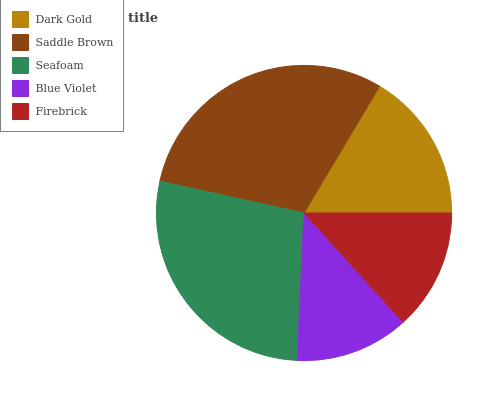Is Blue Violet the minimum?
Answer yes or no. Yes. Is Saddle Brown the maximum?
Answer yes or no. Yes. Is Seafoam the minimum?
Answer yes or no. No. Is Seafoam the maximum?
Answer yes or no. No. Is Saddle Brown greater than Seafoam?
Answer yes or no. Yes. Is Seafoam less than Saddle Brown?
Answer yes or no. Yes. Is Seafoam greater than Saddle Brown?
Answer yes or no. No. Is Saddle Brown less than Seafoam?
Answer yes or no. No. Is Dark Gold the high median?
Answer yes or no. Yes. Is Dark Gold the low median?
Answer yes or no. Yes. Is Blue Violet the high median?
Answer yes or no. No. Is Firebrick the low median?
Answer yes or no. No. 